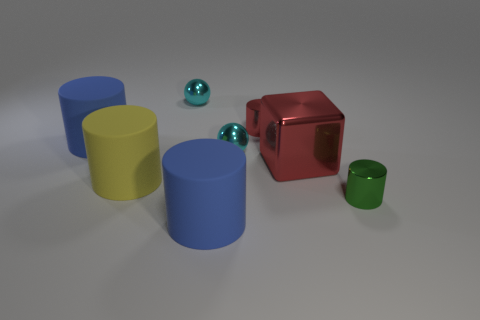Subtract all red cylinders. How many cylinders are left? 4 Subtract all yellow rubber cylinders. How many cylinders are left? 4 Subtract all cyan cylinders. Subtract all yellow blocks. How many cylinders are left? 5 Add 1 red things. How many objects exist? 9 Subtract all cylinders. How many objects are left? 3 Subtract all cylinders. Subtract all tiny cyan metal things. How many objects are left? 1 Add 4 small red metallic cylinders. How many small red metallic cylinders are left? 5 Add 4 large cyan objects. How many large cyan objects exist? 4 Subtract 1 red cubes. How many objects are left? 7 